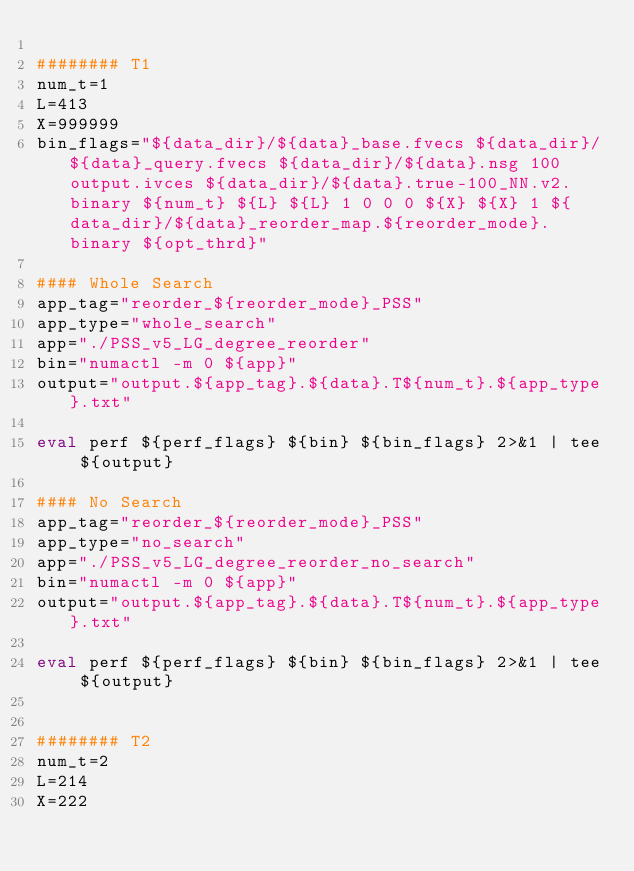Convert code to text. <code><loc_0><loc_0><loc_500><loc_500><_Bash_>
######## T1
num_t=1
L=413
X=999999
bin_flags="${data_dir}/${data}_base.fvecs ${data_dir}/${data}_query.fvecs ${data_dir}/${data}.nsg 100 output.ivces ${data_dir}/${data}.true-100_NN.v2.binary ${num_t} ${L} ${L} 1 0 0 0 ${X} ${X} 1 ${data_dir}/${data}_reorder_map.${reorder_mode}.binary ${opt_thrd}"

#### Whole Search
app_tag="reorder_${reorder_mode}_PSS"
app_type="whole_search"
app="./PSS_v5_LG_degree_reorder"
bin="numactl -m 0 ${app}"
output="output.${app_tag}.${data}.T${num_t}.${app_type}.txt"

eval perf ${perf_flags} ${bin} ${bin_flags} 2>&1 | tee ${output}

#### No Search
app_tag="reorder_${reorder_mode}_PSS"
app_type="no_search"
app="./PSS_v5_LG_degree_reorder_no_search"
bin="numactl -m 0 ${app}"
output="output.${app_tag}.${data}.T${num_t}.${app_type}.txt"

eval perf ${perf_flags} ${bin} ${bin_flags} 2>&1 | tee ${output}


######## T2
num_t=2
L=214
X=222</code> 